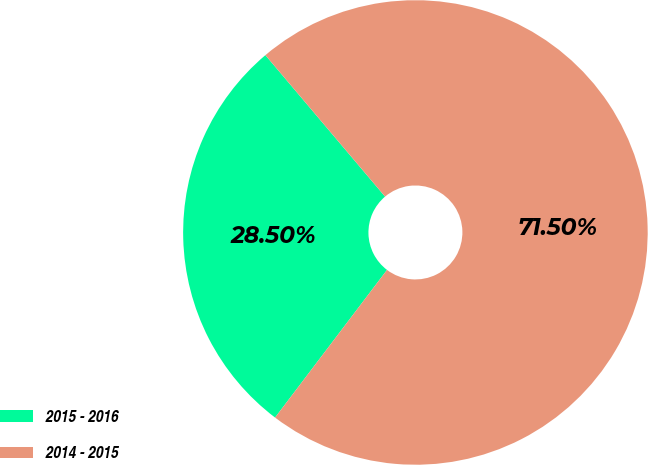<chart> <loc_0><loc_0><loc_500><loc_500><pie_chart><fcel>2015 - 2016<fcel>2014 - 2015<nl><fcel>28.5%<fcel>71.5%<nl></chart> 